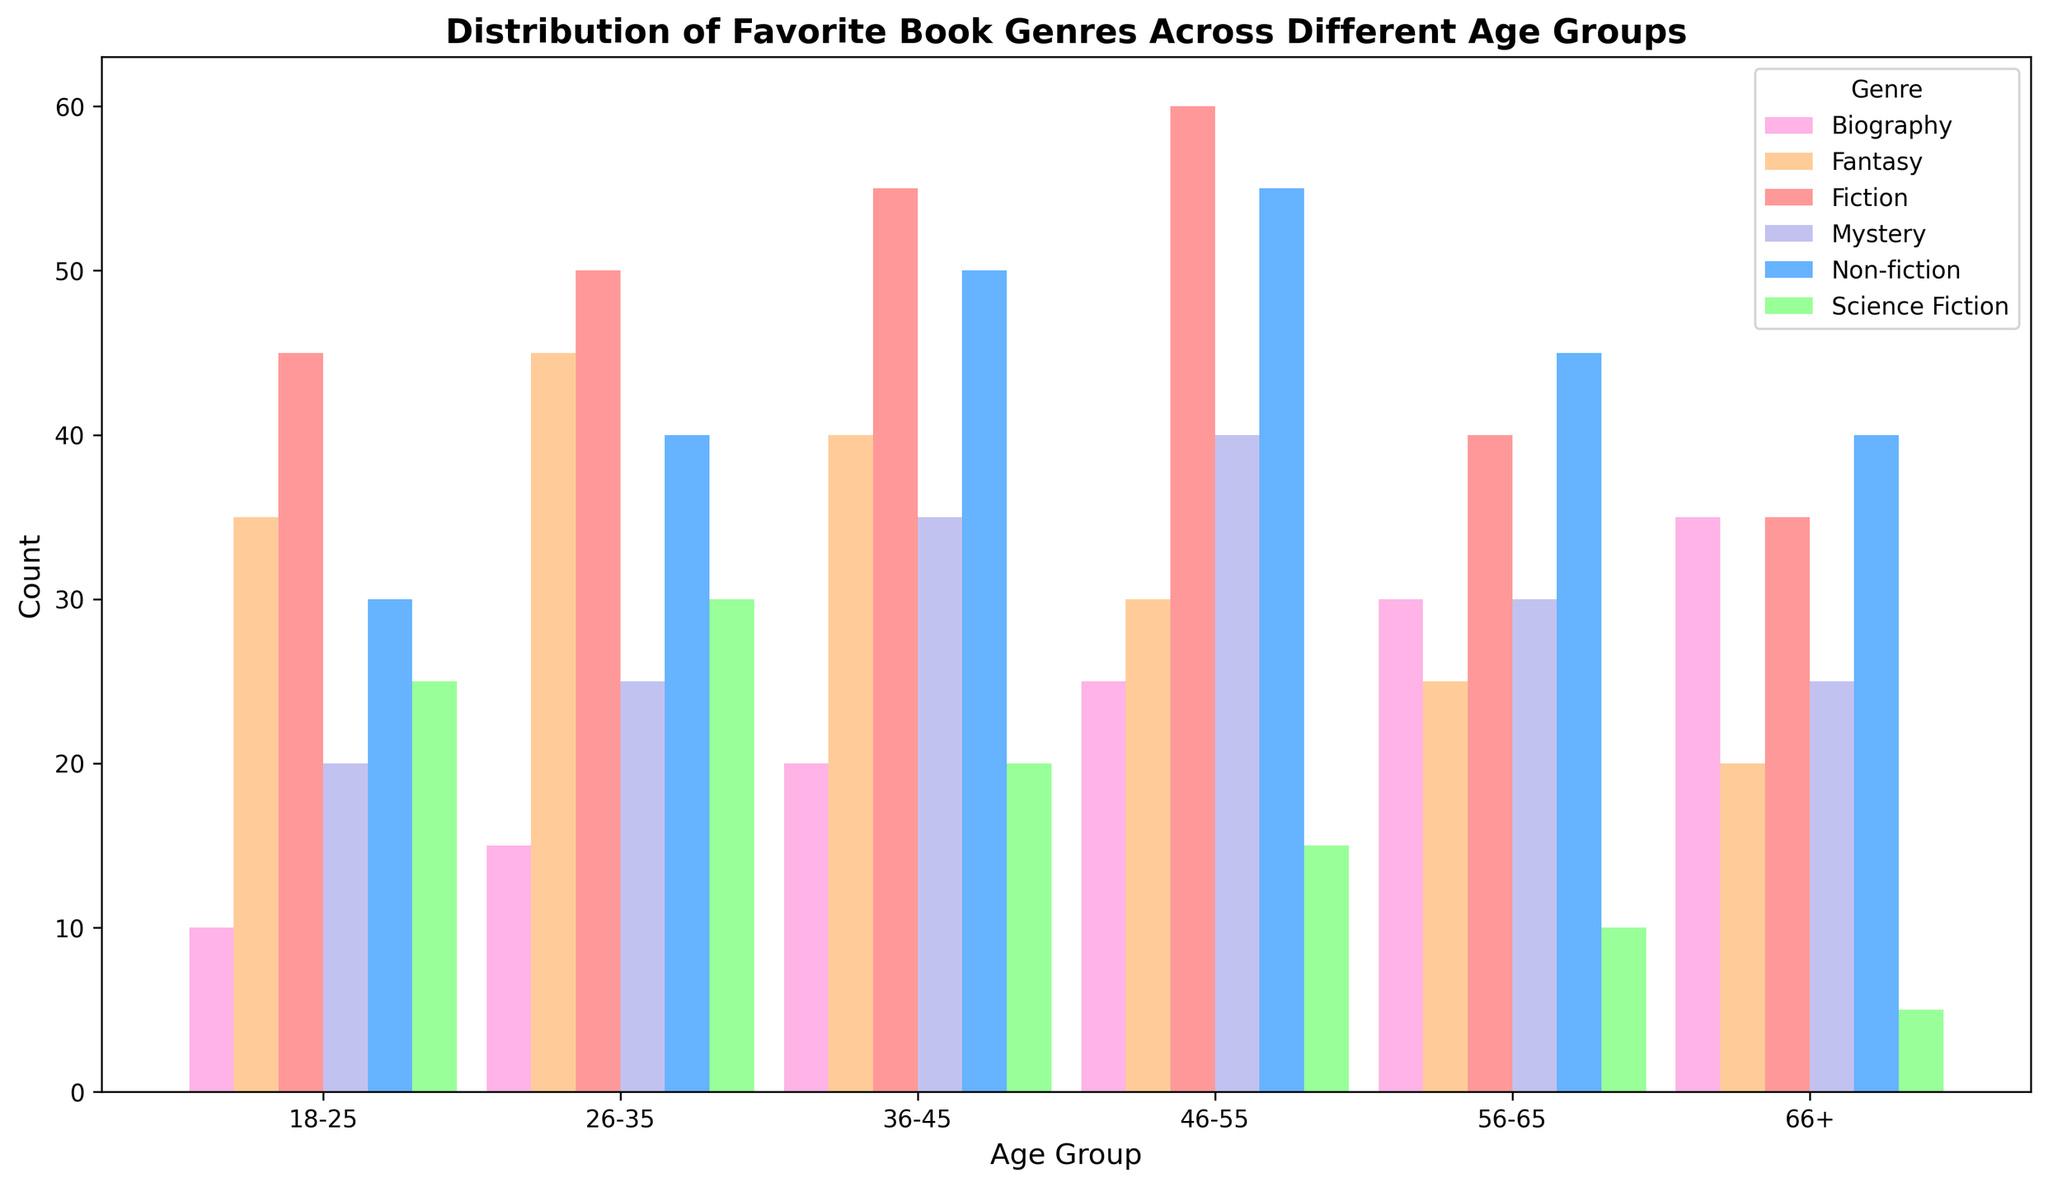Which age group prefers Fiction the most? The height of the bar for Fiction is the tallest for the 46-55 age group compared to other age groups.
Answer: 46-55 What is the sum of Non-fiction readers in the 18-25 and 26-35 age groups? The count of Non-fiction readers in the 18-25 age group is 30, and in the 26-35 age group is 40. Summing these gives 30 + 40 = 70.
Answer: 70 Which genre has the least number of readers in the 66+ age group? The shortest bar in the 66+ age group is for Science Fiction with a height representing 5 readers.
Answer: Science Fiction For the 36-45 age group, is Mystery more popular than Science Fiction? The bar for Mystery in the 36-45 age group is taller than the bar for Science Fiction, indicating a higher count (Mystery: 35, Science Fiction: 20).
Answer: Yes What is the difference in the number of Fantasy readers between the 18-25 and 46-55 age groups? The count of Fantasy readers is 35 in the 18-25 age group and 30 in the 46-55 age group. The difference is 35 - 30 = 5.
Answer: 5 What is the total count of Biography readers across all age groups? Adding the counts for Biography across all age groups: 10 + 15 + 20 + 25 + 30 + 35 = 135.
Answer: 135 Which age group has the highest preference for Mystery? The bar for Mystery is tallest in the 46-55 age group compared to other age groups.
Answer: 46-55 Which genre shows a consistent increase in the number of readers as age increases until 46-55? The bar heights for Fiction consistently increase with each age group until peaking at 46-55.
Answer: Fiction Is the number of Science Fiction readers in the 26-35 age group greater than that in the 46-55 age group? The count of Science Fiction readers in the 26-35 age group is 30, while in the 46-55 age group, it is 15. 30 is greater than 15.
Answer: Yes 